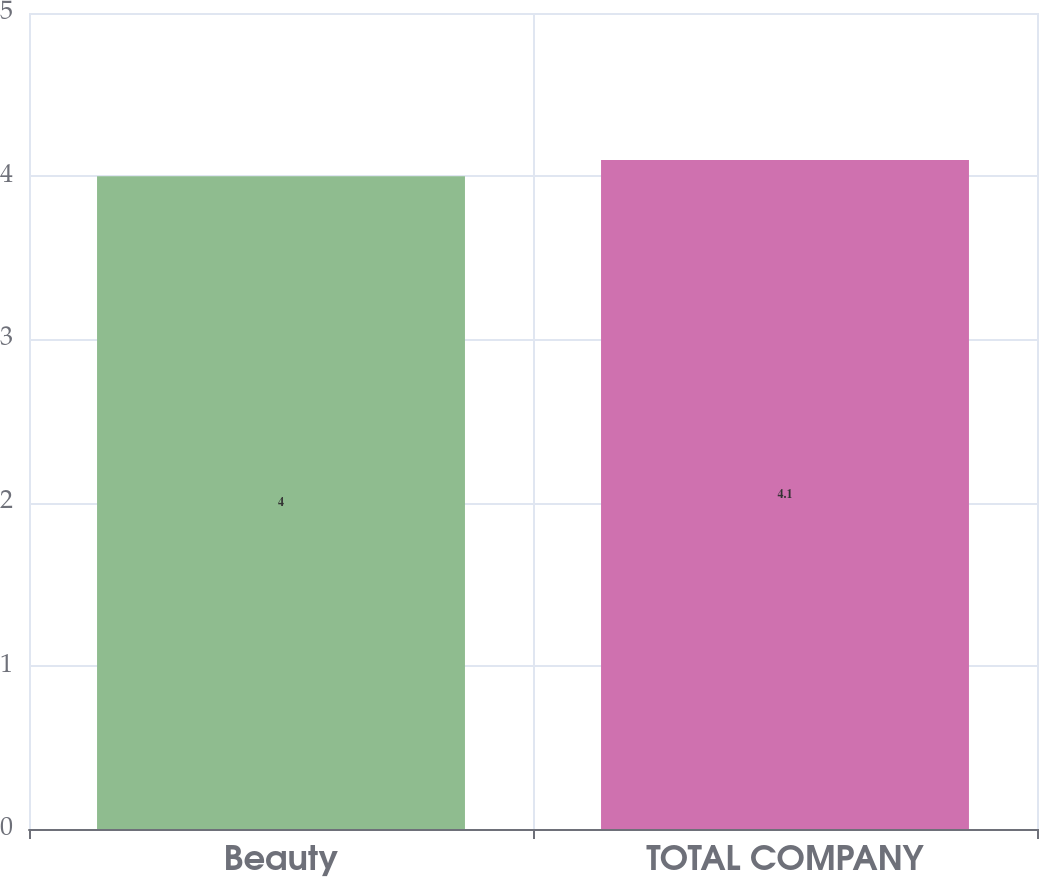Convert chart. <chart><loc_0><loc_0><loc_500><loc_500><bar_chart><fcel>Beauty<fcel>TOTAL COMPANY<nl><fcel>4<fcel>4.1<nl></chart> 